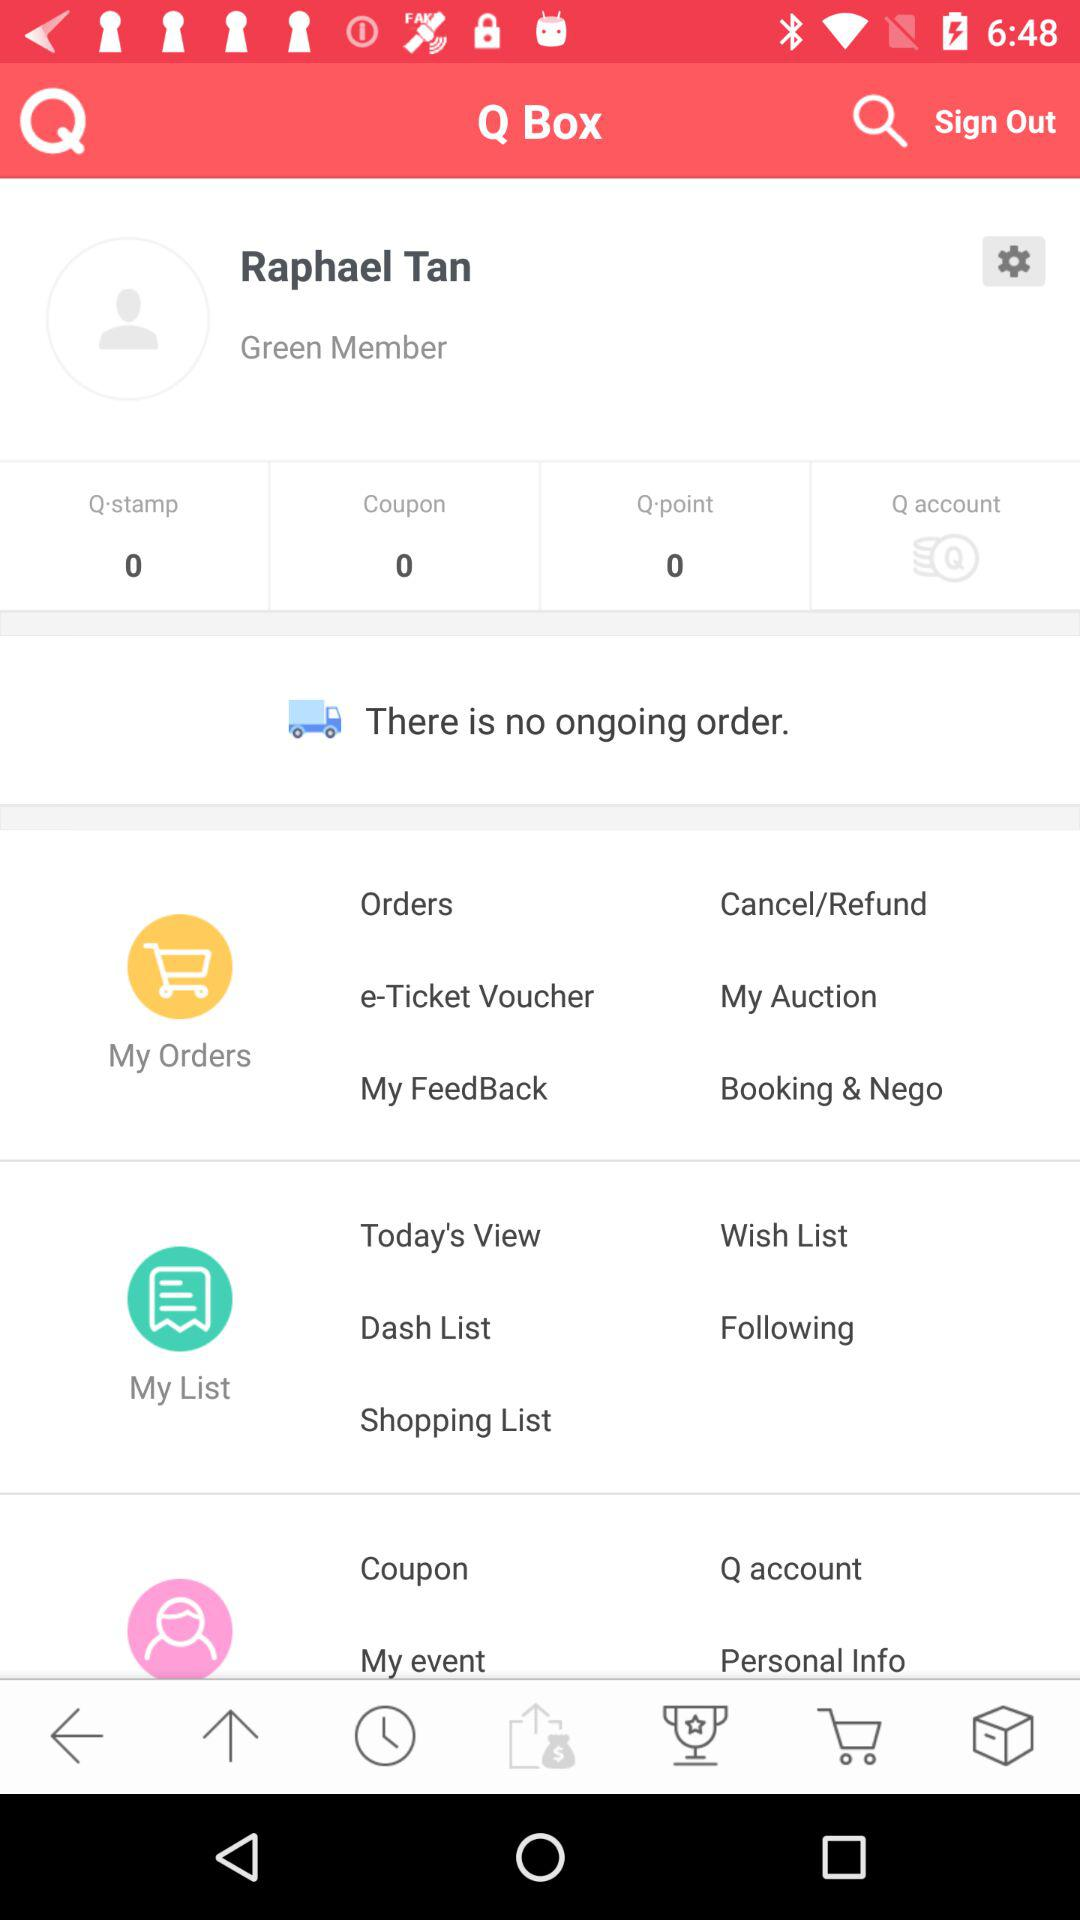How many Q-stamps are there? There are 0 Q-stamps. 